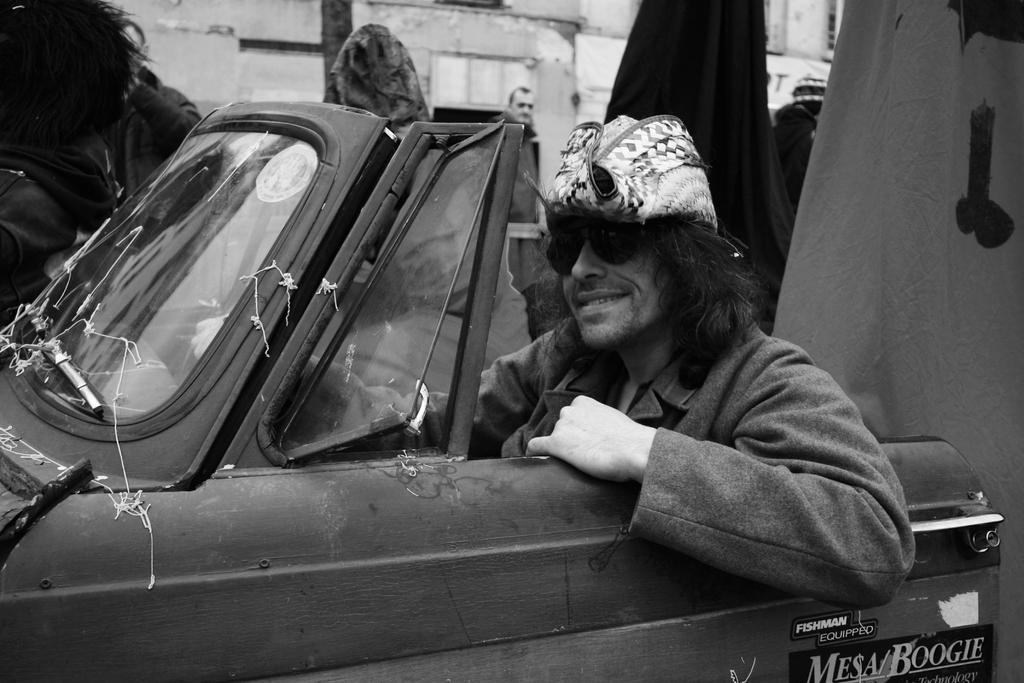What is the main subject of the image? There is a person in a vehicle in the image. Can you describe the setting of the image? The person in the vehicle is in the foreground, and there are persons visible in the background of the image. What type of pin can be seen on the grape in the image? There is no pin or grape present in the image. How many bells are visible in the image? There are no bells visible in the image. 